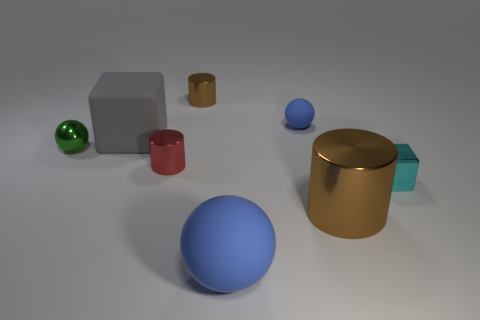Do the big cylinder and the large sphere have the same color?
Your response must be concise. No. What is the shape of the big rubber thing that is the same color as the tiny matte ball?
Your answer should be compact. Sphere. How many green spheres are behind the cube behind the small green sphere?
Your answer should be very brief. 0. What number of small brown cylinders have the same material as the tiny red cylinder?
Offer a very short reply. 1. There is a small blue rubber object; are there any small blocks right of it?
Offer a very short reply. Yes. There is a shiny block that is the same size as the green thing; what is its color?
Your answer should be very brief. Cyan. What number of objects are metal objects in front of the small blue ball or red metal objects?
Offer a terse response. 4. There is a metallic object that is both left of the small cyan block and in front of the tiny red metal thing; what is its size?
Provide a succinct answer. Large. What size is the other matte ball that is the same color as the small rubber sphere?
Your answer should be compact. Large. How many other objects are there of the same size as the green sphere?
Make the answer very short. 4. 